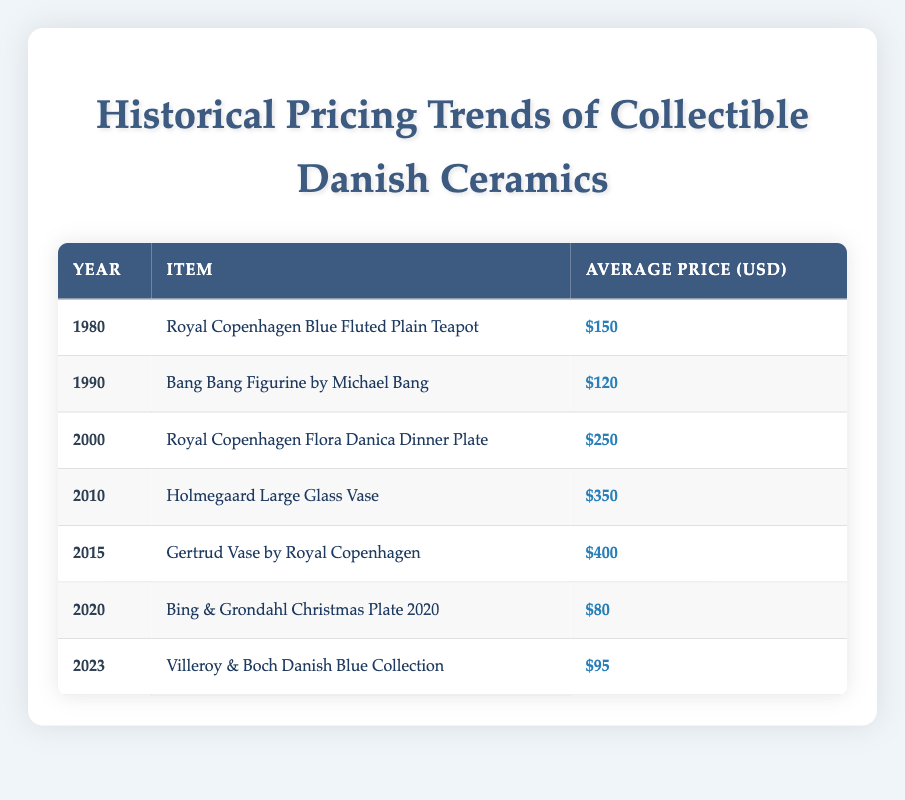What was the average price of the Royal Copenhagen Flora Danica Dinner Plate in 2000? The table shows that the average price of the Royal Copenhagen Flora Danica Dinner Plate in 2000 is listed as $250.
Answer: 250 Which item had the highest average price in 2015? According to the table, the Gertrud Vase by Royal Copenhagen had the highest average price in 2015 at $400.
Answer: 400 Was the average price of the Bing & Grondahl Christmas Plate 2020 higher than the Villeroy & Boch Danish Blue Collection in 2023? The table indicates that the average price of the Bing & Grondahl Christmas Plate in 2020 was $80, while the Villeroy & Boch Danish Blue Collection in 2023 was $95. Since $80 is less than $95, the answer is no.
Answer: No What is the difference in average price between the teapot in 1980 and the vase in 2010? From the table, the average price of the Royal Copenhagen Blue Fluted Plain Teapot in 1980 was $150, and the Holmegaard Large Glass Vase in 2010 was $350. The difference is calculated as $350 - $150 = $200.
Answer: 200 How many items in the table have an average price below $100? The table lists seven items, out of which only the Bing & Grondahl Christmas Plate in 2020 ($80) and the Villeroy & Boch Danish Blue Collection in 2023 ($95) have an average price below $100, which counts as 2 items.
Answer: 2 What was the average price of collectible Danish ceramics from 1980 to 2023? To find the average price, add all the prices: $150 + $120 + $250 + $350 + $400 + $80 + $95 = $1,545. Then, divide by the number of items (7): $1,545 / 7 = approximately $220.71.
Answer: 220.71 Which item experienced the most significant price increase from 1980 to 2015? In 1980, the Royal Copenhagen Blue Fluted Plain Teapot was priced at $150, and in 2015, the Gertrud Vase was priced at $400. The increase is calculated as $400 - $150 = $250. No other item shows a higher increase.
Answer: 250 Did any item see a decrease in average price between the years 2015 and 2020? The table shows that in 2015, the Gertrud Vase was priced at $400 and in 2020, the Bing & Grondahl Christmas Plate was priced at $80. Since $80 is lower than $400, this indicates a decrease.
Answer: Yes 